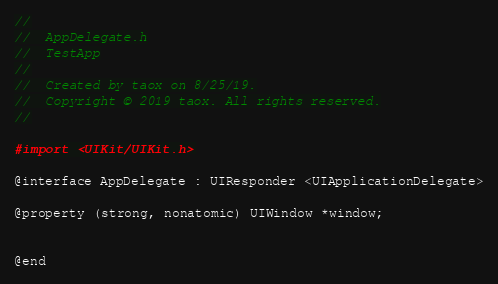<code> <loc_0><loc_0><loc_500><loc_500><_C_>//
//  AppDelegate.h
//  TestApp
//
//  Created by taox on 8/25/19.
//  Copyright © 2019 taox. All rights reserved.
//

#import <UIKit/UIKit.h>

@interface AppDelegate : UIResponder <UIApplicationDelegate>

@property (strong, nonatomic) UIWindow *window;


@end

</code> 